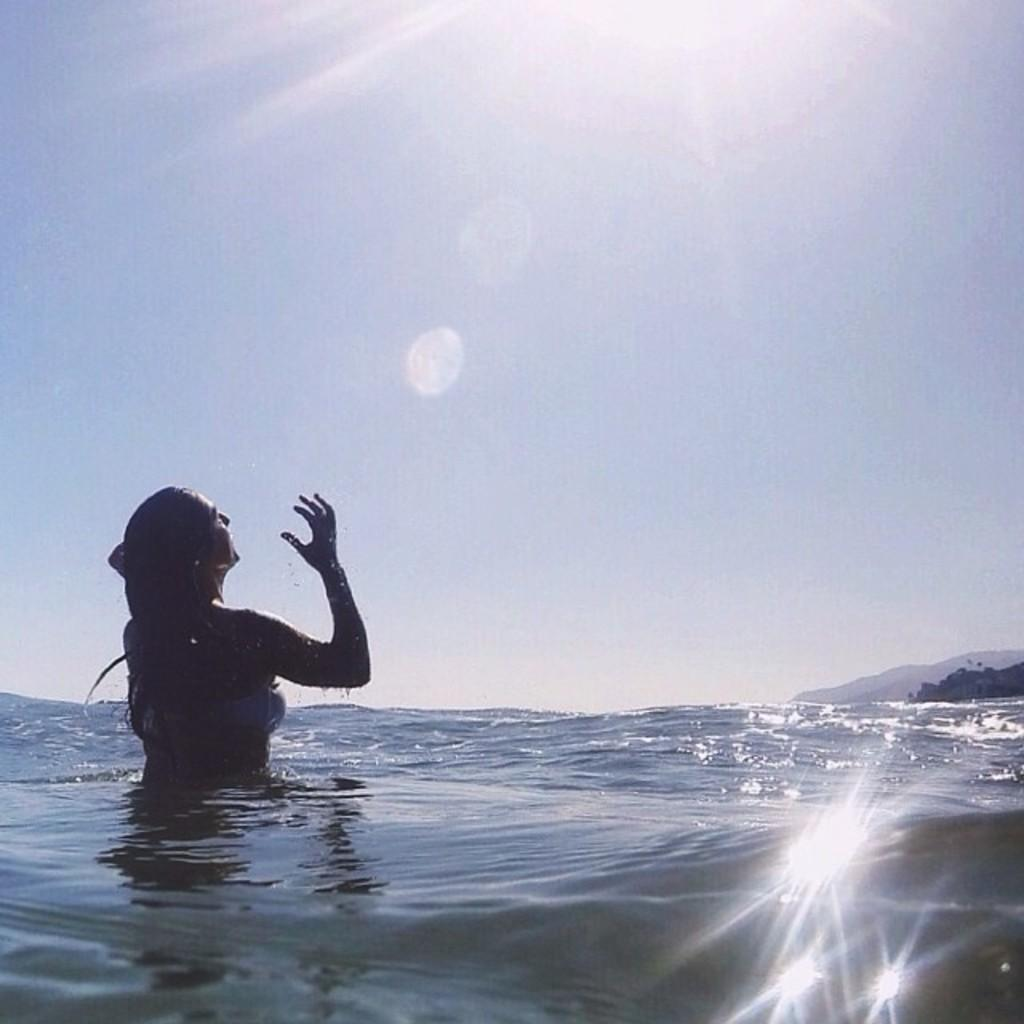Who is present in the image? There is a woman in the image. What is the woman doing in the image? The woman is taking a bath in the water. How is the woman being illuminated in the image? Sunlight is falling on the woman. What type of rice is being cooked in the image? There is no rice present in the image; it features a woman taking a bath in the water. What color is the dress the woman is wearing in the image? The woman is not wearing a dress in the image; she is taking a bath in the water. 